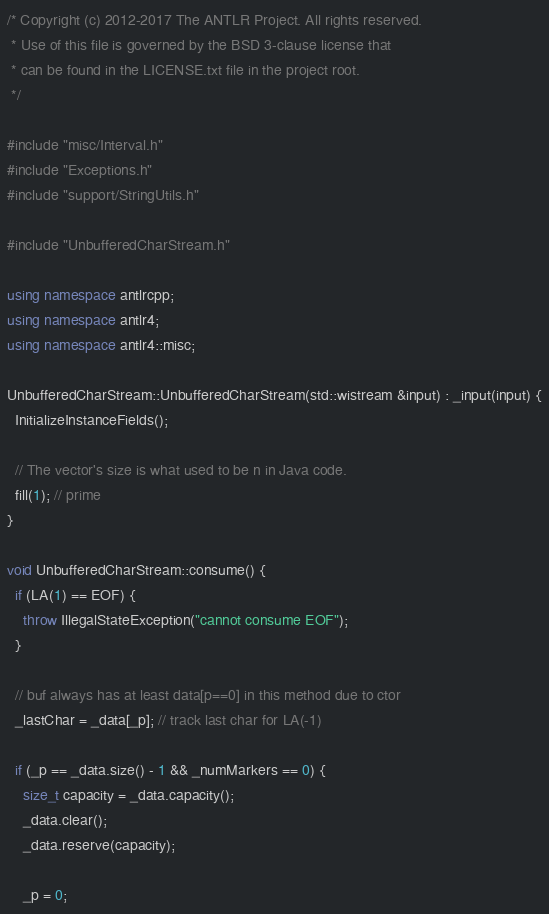Convert code to text. <code><loc_0><loc_0><loc_500><loc_500><_C++_>/* Copyright (c) 2012-2017 The ANTLR Project. All rights reserved.
 * Use of this file is governed by the BSD 3-clause license that
 * can be found in the LICENSE.txt file in the project root.
 */

#include "misc/Interval.h"
#include "Exceptions.h"
#include "support/StringUtils.h"

#include "UnbufferedCharStream.h"

using namespace antlrcpp;
using namespace antlr4;
using namespace antlr4::misc;

UnbufferedCharStream::UnbufferedCharStream(std::wistream &input) : _input(input) {
  InitializeInstanceFields();

  // The vector's size is what used to be n in Java code.
  fill(1); // prime
}

void UnbufferedCharStream::consume() {
  if (LA(1) == EOF) {
    throw IllegalStateException("cannot consume EOF");
  }

  // buf always has at least data[p==0] in this method due to ctor
  _lastChar = _data[_p]; // track last char for LA(-1)

  if (_p == _data.size() - 1 && _numMarkers == 0) {
    size_t capacity = _data.capacity();
    _data.clear();
    _data.reserve(capacity);

    _p = 0;</code> 